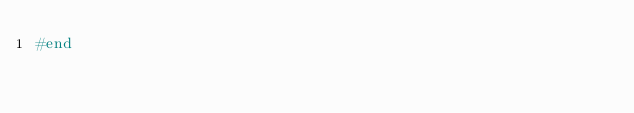<code> <loc_0><loc_0><loc_500><loc_500><_Ruby_>#end
</code> 